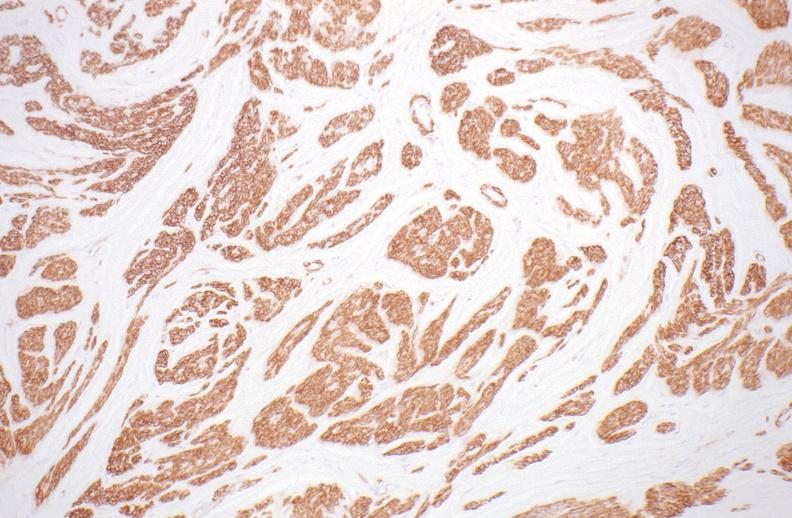do alpha smooth muscle actin immunohistochemical stain?
Answer the question using a single word or phrase. Yes 